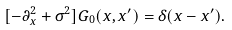Convert formula to latex. <formula><loc_0><loc_0><loc_500><loc_500>[ - \partial _ { x } ^ { 2 } + \sigma ^ { 2 } ] G _ { 0 } ( x , x ^ { \prime } ) = \delta ( x - x ^ { \prime } ) .</formula> 